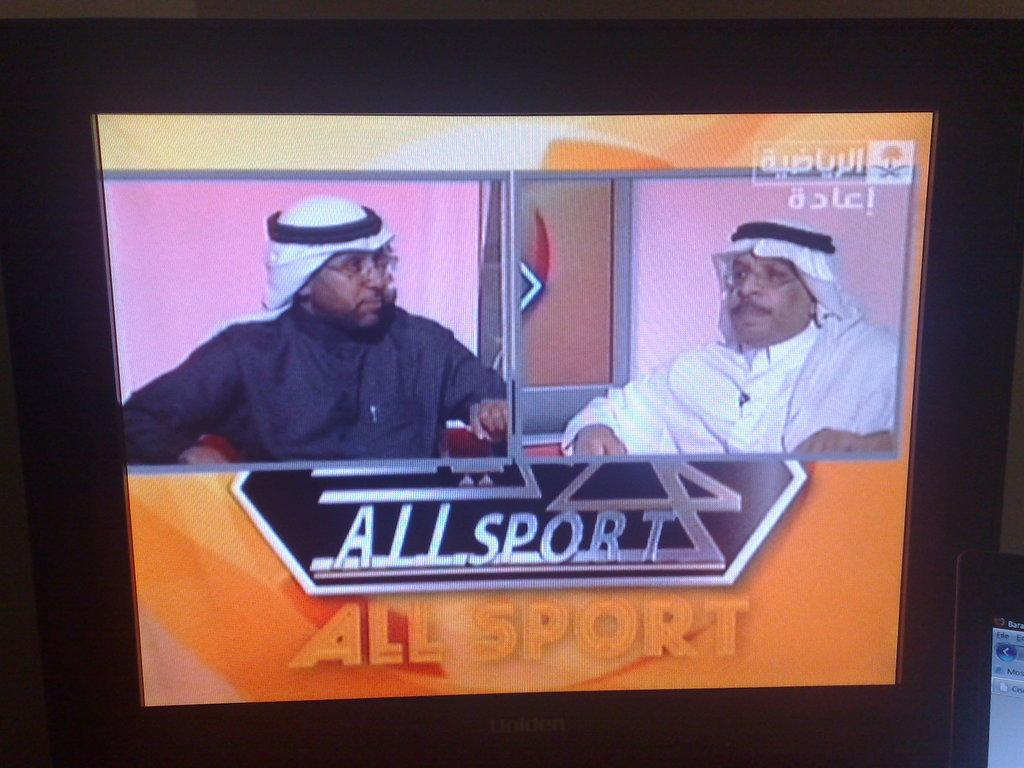<image>
Relay a brief, clear account of the picture shown. A computer monitor with a shot of two men on ALLSPORT. 